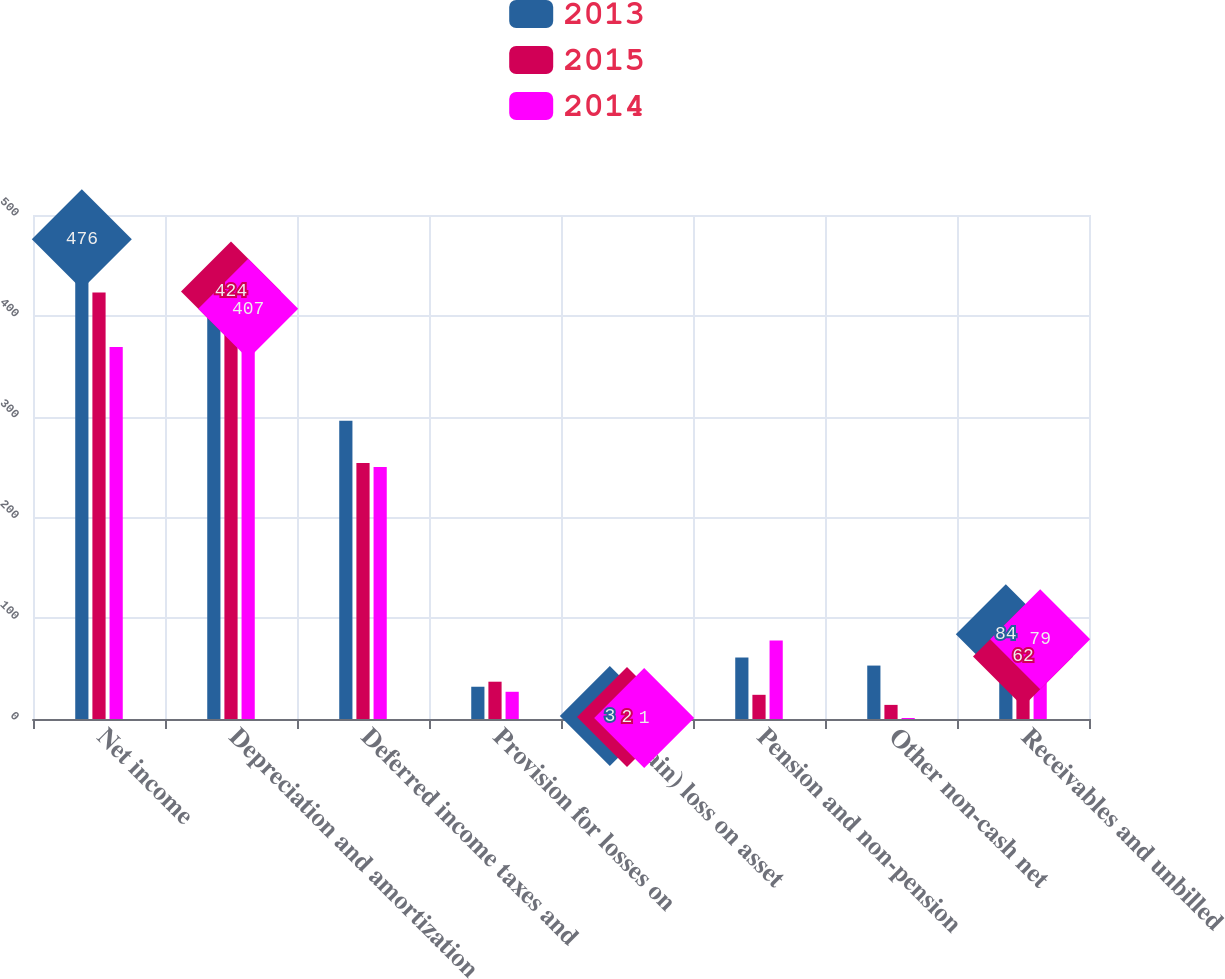Convert chart. <chart><loc_0><loc_0><loc_500><loc_500><stacked_bar_chart><ecel><fcel>Net income<fcel>Depreciation and amortization<fcel>Deferred income taxes and<fcel>Provision for losses on<fcel>(Gain) loss on asset<fcel>Pension and non-pension<fcel>Other non-cash net<fcel>Receivables and unbilled<nl><fcel>2013<fcel>476<fcel>440<fcel>296<fcel>32<fcel>3<fcel>61<fcel>53<fcel>84<nl><fcel>2015<fcel>423<fcel>424<fcel>254<fcel>37<fcel>2<fcel>24<fcel>14<fcel>62<nl><fcel>2014<fcel>369<fcel>407<fcel>250<fcel>27<fcel>1<fcel>78<fcel>1<fcel>79<nl></chart> 